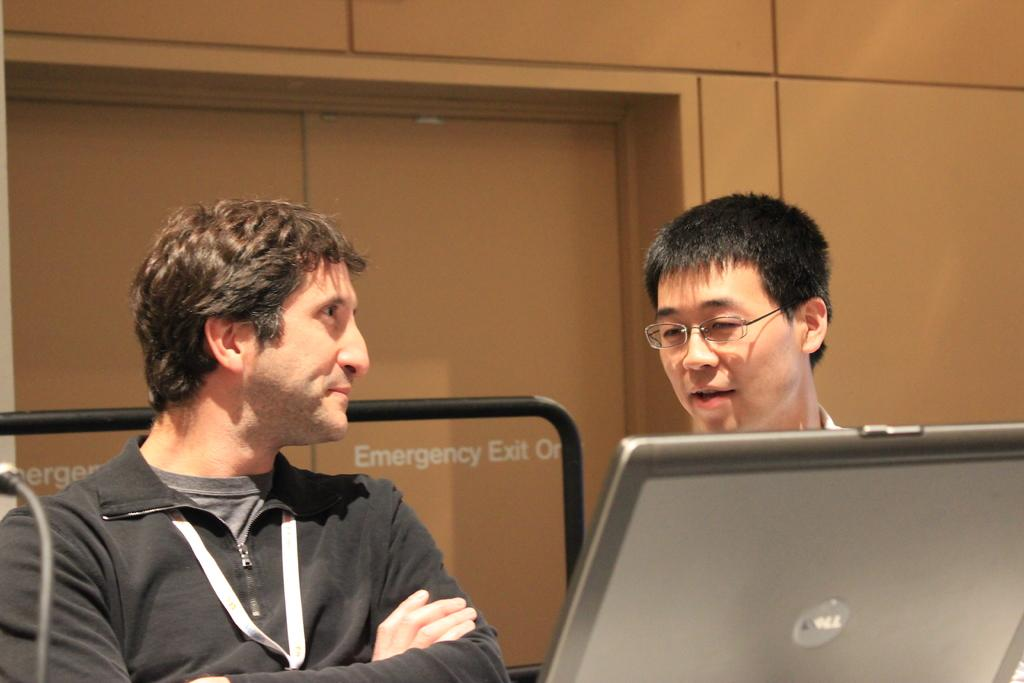How many people are present in the image? There are two persons in the image. What object can be seen with the persons? There is a laptop in the image. What color is the rod visible in the background? The rod in the background of the image is black. What type of structure can be seen in the background? There is a wall in the background of the image. What is written on the door in the background? There is a door with text in the background of the image. What grade does the government assign to the laptop in the image? There is no mention of a grade or government involvement in the image; it simply shows two people and a laptop. 